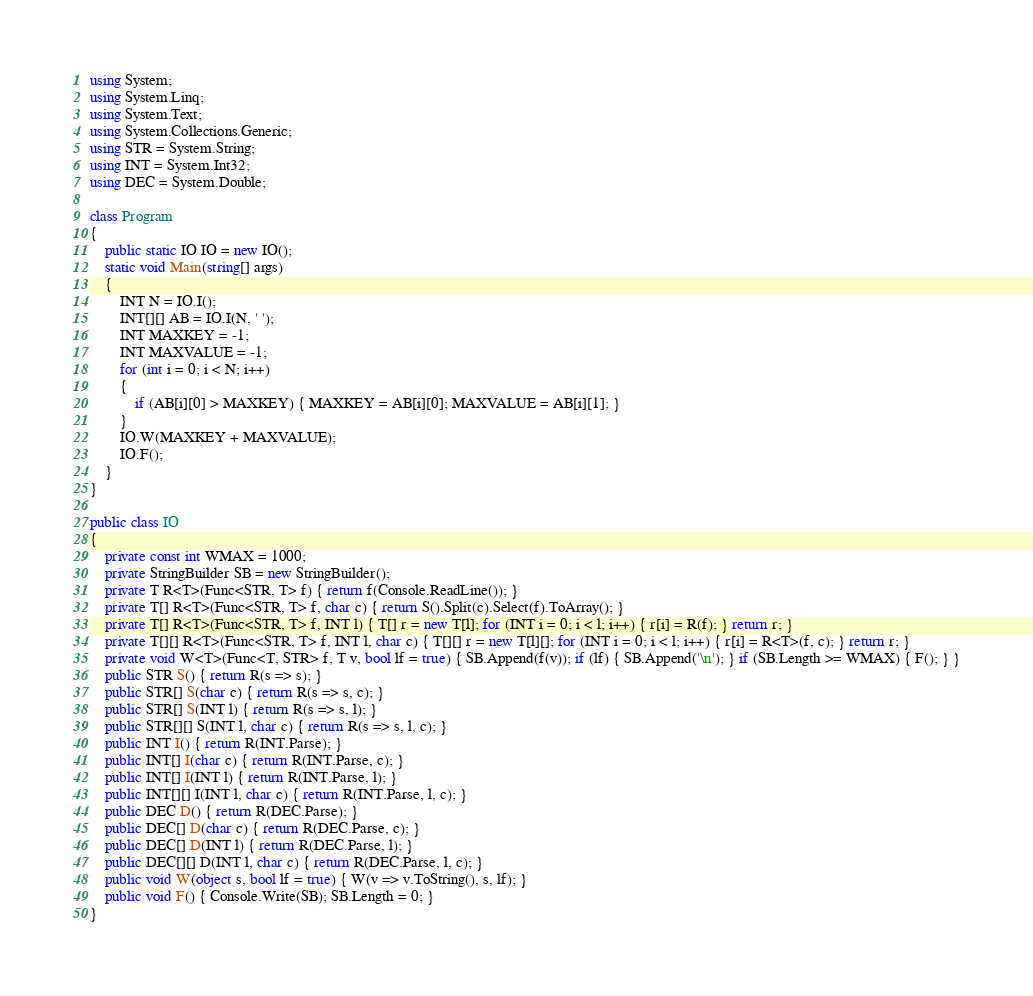Convert code to text. <code><loc_0><loc_0><loc_500><loc_500><_C#_>using System;
using System.Linq;
using System.Text;
using System.Collections.Generic;
using STR = System.String;
using INT = System.Int32;
using DEC = System.Double;

class Program
{
    public static IO IO = new IO();
    static void Main(string[] args)
    {
        INT N = IO.I();
        INT[][] AB = IO.I(N, ' ');
        INT MAXKEY = -1;
        INT MAXVALUE = -1;
        for (int i = 0; i < N; i++)
        {
            if (AB[i][0] > MAXKEY) { MAXKEY = AB[i][0]; MAXVALUE = AB[i][1]; }
        }
        IO.W(MAXKEY + MAXVALUE);
        IO.F();
    }
}

public class IO
{
    private const int WMAX = 1000;
    private StringBuilder SB = new StringBuilder();
    private T R<T>(Func<STR, T> f) { return f(Console.ReadLine()); }
    private T[] R<T>(Func<STR, T> f, char c) { return S().Split(c).Select(f).ToArray(); }
    private T[] R<T>(Func<STR, T> f, INT l) { T[] r = new T[l]; for (INT i = 0; i < l; i++) { r[i] = R(f); } return r; }
    private T[][] R<T>(Func<STR, T> f, INT l, char c) { T[][] r = new T[l][]; for (INT i = 0; i < l; i++) { r[i] = R<T>(f, c); } return r; }
    private void W<T>(Func<T, STR> f, T v, bool lf = true) { SB.Append(f(v)); if (lf) { SB.Append('\n'); } if (SB.Length >= WMAX) { F(); } }
    public STR S() { return R(s => s); }
    public STR[] S(char c) { return R(s => s, c); }
    public STR[] S(INT l) { return R(s => s, l); }
    public STR[][] S(INT l, char c) { return R(s => s, l, c); }
    public INT I() { return R(INT.Parse); }
    public INT[] I(char c) { return R(INT.Parse, c); }
    public INT[] I(INT l) { return R(INT.Parse, l); }
    public INT[][] I(INT l, char c) { return R(INT.Parse, l, c); }
    public DEC D() { return R(DEC.Parse); }
    public DEC[] D(char c) { return R(DEC.Parse, c); }
    public DEC[] D(INT l) { return R(DEC.Parse, l); }
    public DEC[][] D(INT l, char c) { return R(DEC.Parse, l, c); }
    public void W(object s, bool lf = true) { W(v => v.ToString(), s, lf); }
    public void F() { Console.Write(SB); SB.Length = 0; }
}</code> 